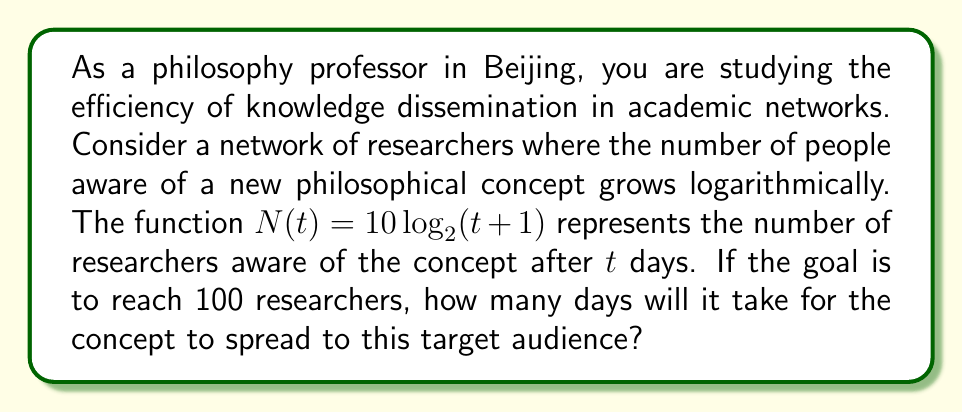Can you answer this question? To solve this problem, we need to use the given logarithmic function and solve for $t$ when $N(t) = 100$. Let's approach this step-by-step:

1) We start with the equation:
   $N(t) = 10 \log_2(t+1)$

2) We want to find $t$ when $N(t) = 100$, so we set up the equation:
   $100 = 10 \log_2(t+1)$

3) Divide both sides by 10:
   $10 = \log_2(t+1)$

4) To solve for $t$, we need to apply the inverse function (exponential) to both sides:
   $2^{10} = t+1$

5) Simplify the left side:
   $1024 = t+1$

6) Subtract 1 from both sides to isolate $t$:
   $1023 = t$

Therefore, it will take 1023 days for the concept to spread to 100 researchers in the network.

This logarithmic model reflects the nature of information spread in academic networks, where initial growth is rapid but slows down over time as the concept reaches saturation within the community. As a philosophy professor, this model can help you understand and predict the dissemination of new philosophical ideas within academic circles.
Answer: 1023 days 